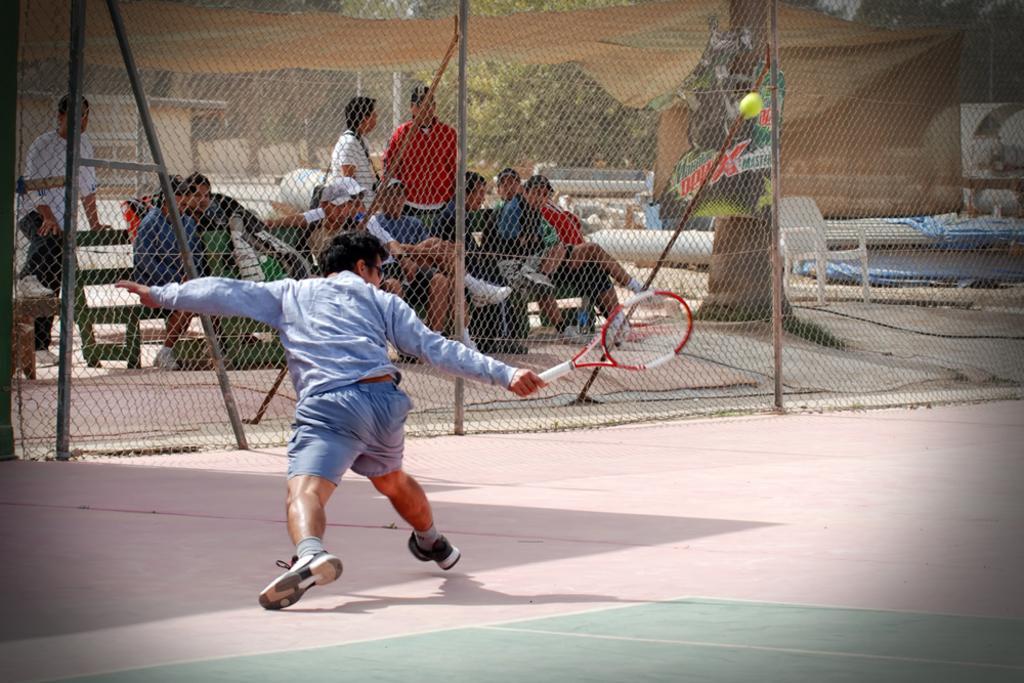Describe this image in one or two sentences. In the image there is a boy hitting ball with tennis racket and in front of him there is net and behind it there are many people sitting on bench, in the background there are trees. 